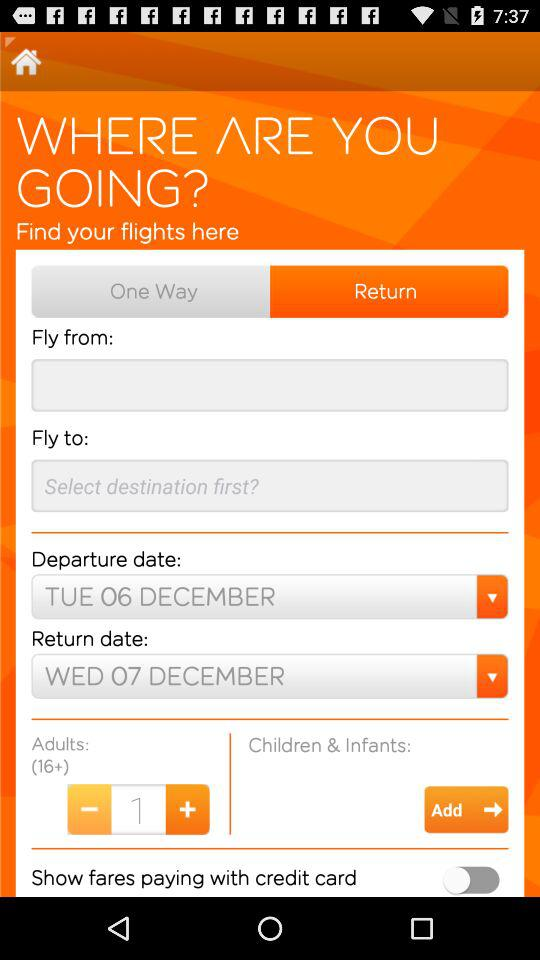How many adults are there? There is 1 adult. 